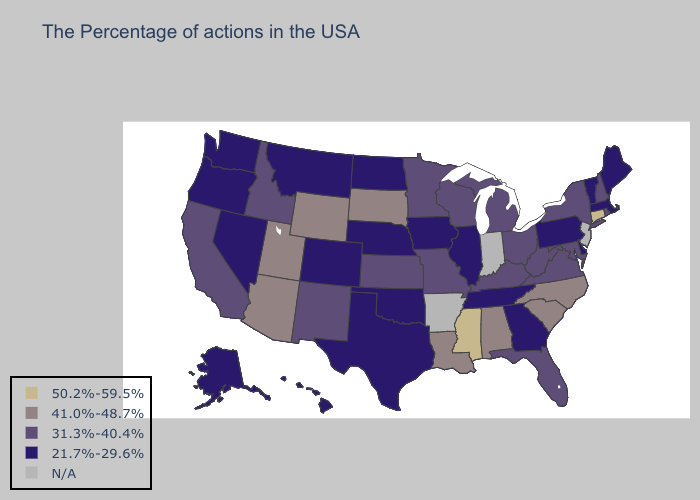Name the states that have a value in the range 31.3%-40.4%?
Give a very brief answer. Rhode Island, New Hampshire, New York, Maryland, Virginia, West Virginia, Ohio, Florida, Michigan, Kentucky, Wisconsin, Missouri, Minnesota, Kansas, New Mexico, Idaho, California. Does Colorado have the lowest value in the USA?
Concise answer only. Yes. What is the highest value in states that border Kentucky?
Quick response, please. 31.3%-40.4%. Which states have the highest value in the USA?
Keep it brief. Connecticut, Mississippi. Which states have the lowest value in the USA?
Short answer required. Maine, Massachusetts, Vermont, Delaware, Pennsylvania, Georgia, Tennessee, Illinois, Iowa, Nebraska, Oklahoma, Texas, North Dakota, Colorado, Montana, Nevada, Washington, Oregon, Alaska, Hawaii. Name the states that have a value in the range 41.0%-48.7%?
Keep it brief. North Carolina, South Carolina, Alabama, Louisiana, South Dakota, Wyoming, Utah, Arizona. Does Connecticut have the highest value in the USA?
Concise answer only. Yes. What is the value of Kansas?
Keep it brief. 31.3%-40.4%. What is the highest value in states that border Nevada?
Answer briefly. 41.0%-48.7%. What is the lowest value in the Northeast?
Concise answer only. 21.7%-29.6%. Name the states that have a value in the range 31.3%-40.4%?
Write a very short answer. Rhode Island, New Hampshire, New York, Maryland, Virginia, West Virginia, Ohio, Florida, Michigan, Kentucky, Wisconsin, Missouri, Minnesota, Kansas, New Mexico, Idaho, California. What is the value of Alaska?
Concise answer only. 21.7%-29.6%. What is the value of Minnesota?
Short answer required. 31.3%-40.4%. 